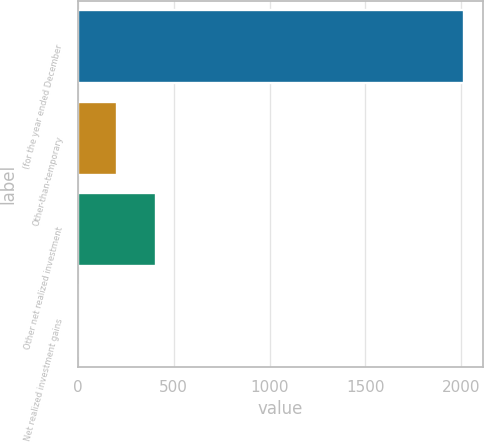Convert chart to OTSL. <chart><loc_0><loc_0><loc_500><loc_500><bar_chart><fcel>(for the year ended December<fcel>Other-than-temporary<fcel>Other net realized investment<fcel>Net realized investment gains<nl><fcel>2015<fcel>204.2<fcel>405.4<fcel>3<nl></chart> 